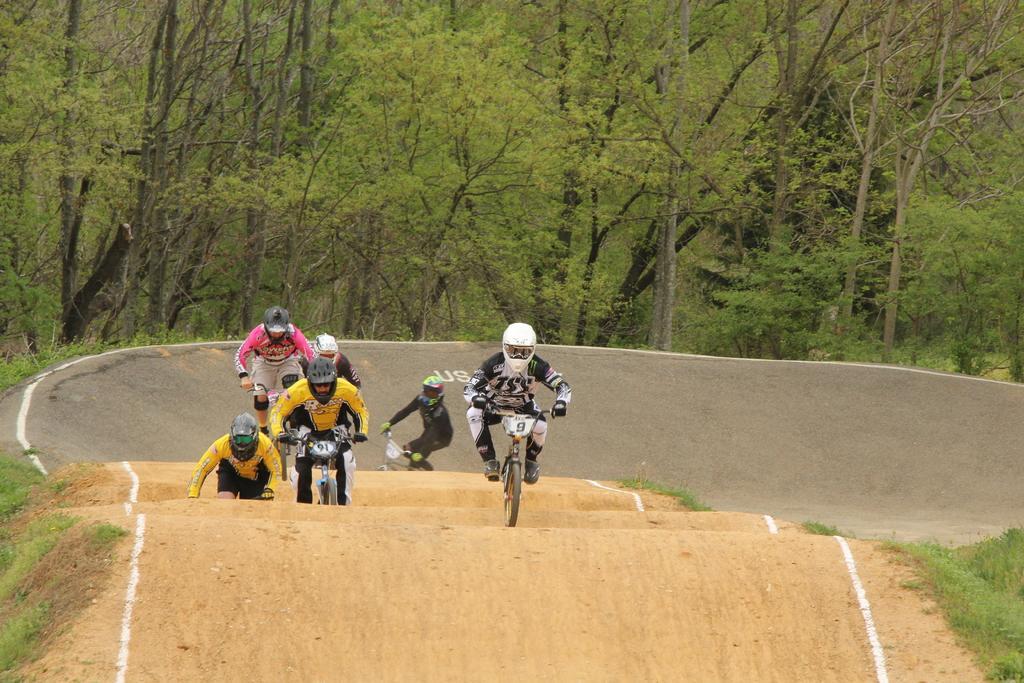Can you describe this image briefly? In this picture I can observe some people on the bicycles. They are wearing helmets. They are racing with bicycles. In the background there are trees. 